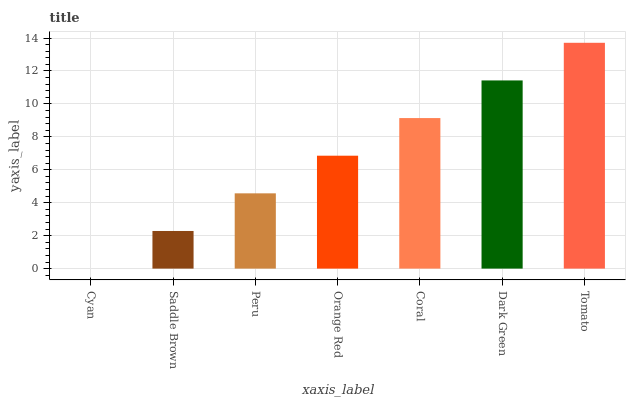Is Cyan the minimum?
Answer yes or no. Yes. Is Tomato the maximum?
Answer yes or no. Yes. Is Saddle Brown the minimum?
Answer yes or no. No. Is Saddle Brown the maximum?
Answer yes or no. No. Is Saddle Brown greater than Cyan?
Answer yes or no. Yes. Is Cyan less than Saddle Brown?
Answer yes or no. Yes. Is Cyan greater than Saddle Brown?
Answer yes or no. No. Is Saddle Brown less than Cyan?
Answer yes or no. No. Is Orange Red the high median?
Answer yes or no. Yes. Is Orange Red the low median?
Answer yes or no. Yes. Is Tomato the high median?
Answer yes or no. No. Is Coral the low median?
Answer yes or no. No. 